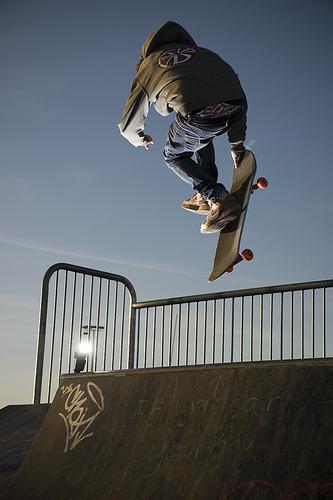What is this person riding?
Be succinct. Skateboard. Does the young man have enough light to see what he's doing?
Quick response, please. Yes. What is written on the ramp?
Be succinct. Graffiti. Is he about to fall?
Answer briefly. No. Is this a bridge?
Short answer required. No. Is the trying to jump over the fence?
Short answer required. No. 